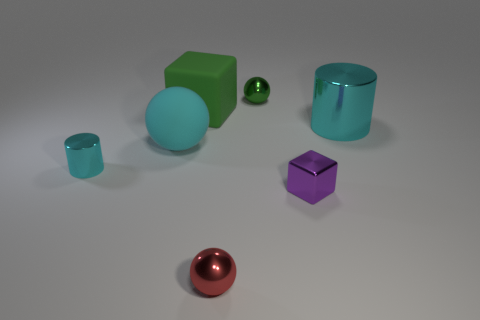How many tiny cyan things are made of the same material as the red object?
Your answer should be very brief. 1. There is a metal thing that is in front of the purple thing; is it the same size as the metallic thing left of the matte cube?
Provide a succinct answer. Yes. There is a matte thing behind the cyan shiny object that is on the right side of the green thing left of the red ball; what color is it?
Make the answer very short. Green. Are there any green things of the same shape as the small purple shiny object?
Your answer should be compact. Yes. Are there an equal number of large cylinders in front of the small purple cube and small red metal things that are in front of the big green thing?
Provide a succinct answer. No. There is a red object that is in front of the small green shiny sphere; does it have the same shape as the purple thing?
Make the answer very short. No. Is the tiny red shiny object the same shape as the small cyan thing?
Offer a terse response. No. How many metal things are either spheres or cyan spheres?
Your response must be concise. 2. There is a tiny sphere that is the same color as the large cube; what material is it?
Your answer should be compact. Metal. Is the metal cube the same size as the green metallic thing?
Provide a short and direct response. Yes. 